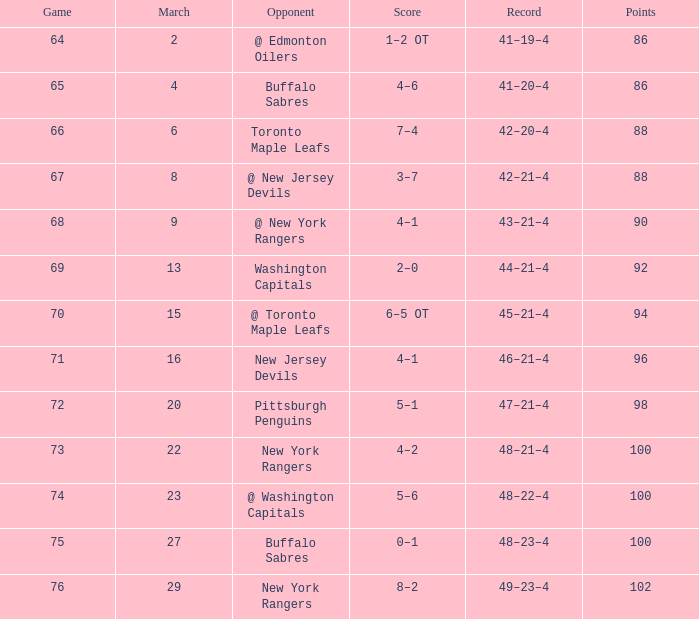Which points have a record of 45-21-4, and a game surpassing 70? None. 